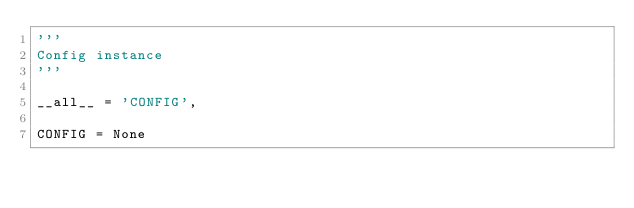<code> <loc_0><loc_0><loc_500><loc_500><_Python_>'''
Config instance
'''

__all__ = 'CONFIG',

CONFIG = None
</code> 